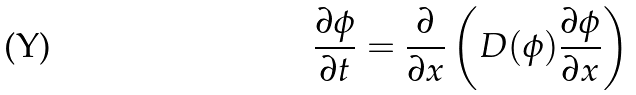<formula> <loc_0><loc_0><loc_500><loc_500>\frac { \partial \phi } { \partial t } = \frac { \partial } { \partial x } \left ( D ( \phi ) \frac { \partial \phi } { \partial x } \right )</formula> 